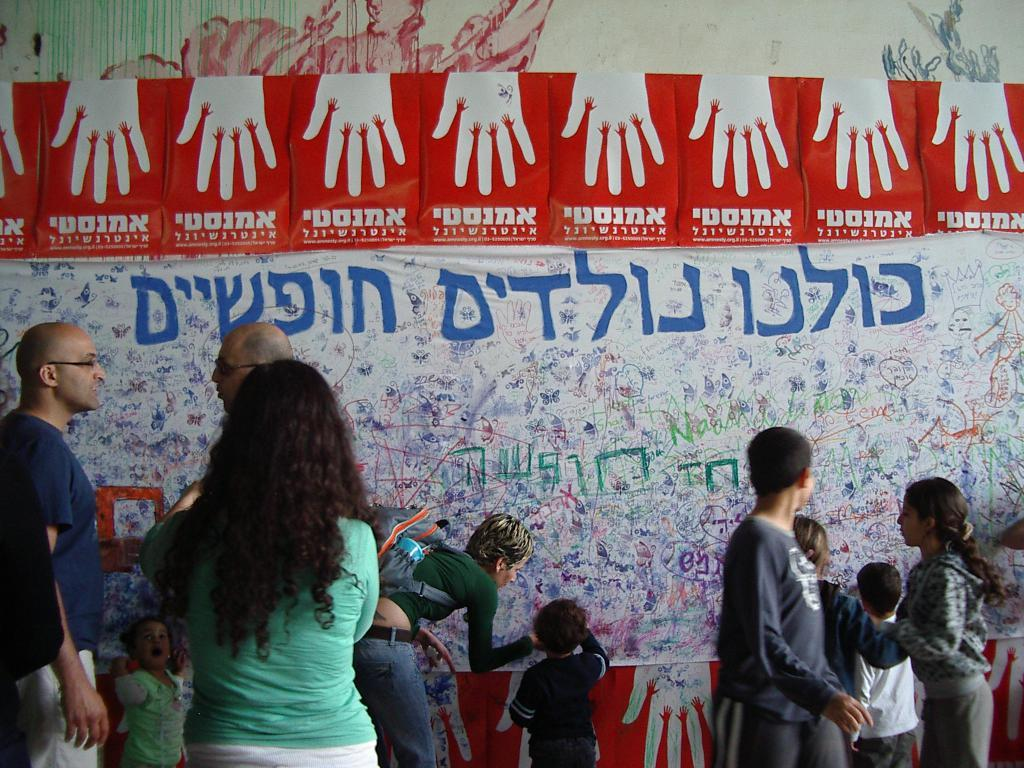Who or what can be seen in the image? There are people in the image. What else is present in the image besides the people? There are banners in the image. Can you describe the banners in more detail? The banners have text, images, and drawings on them. What is visible in the background of the image? There is a wall in the background of the image. What type of bubble can be seen floating in the image? There is no bubble present in the image. What time of day is it in the image, considering the presence of morning light? The provided facts do not mention any specific time of day or lighting conditions, so it cannot be determined if it is morning or not. 